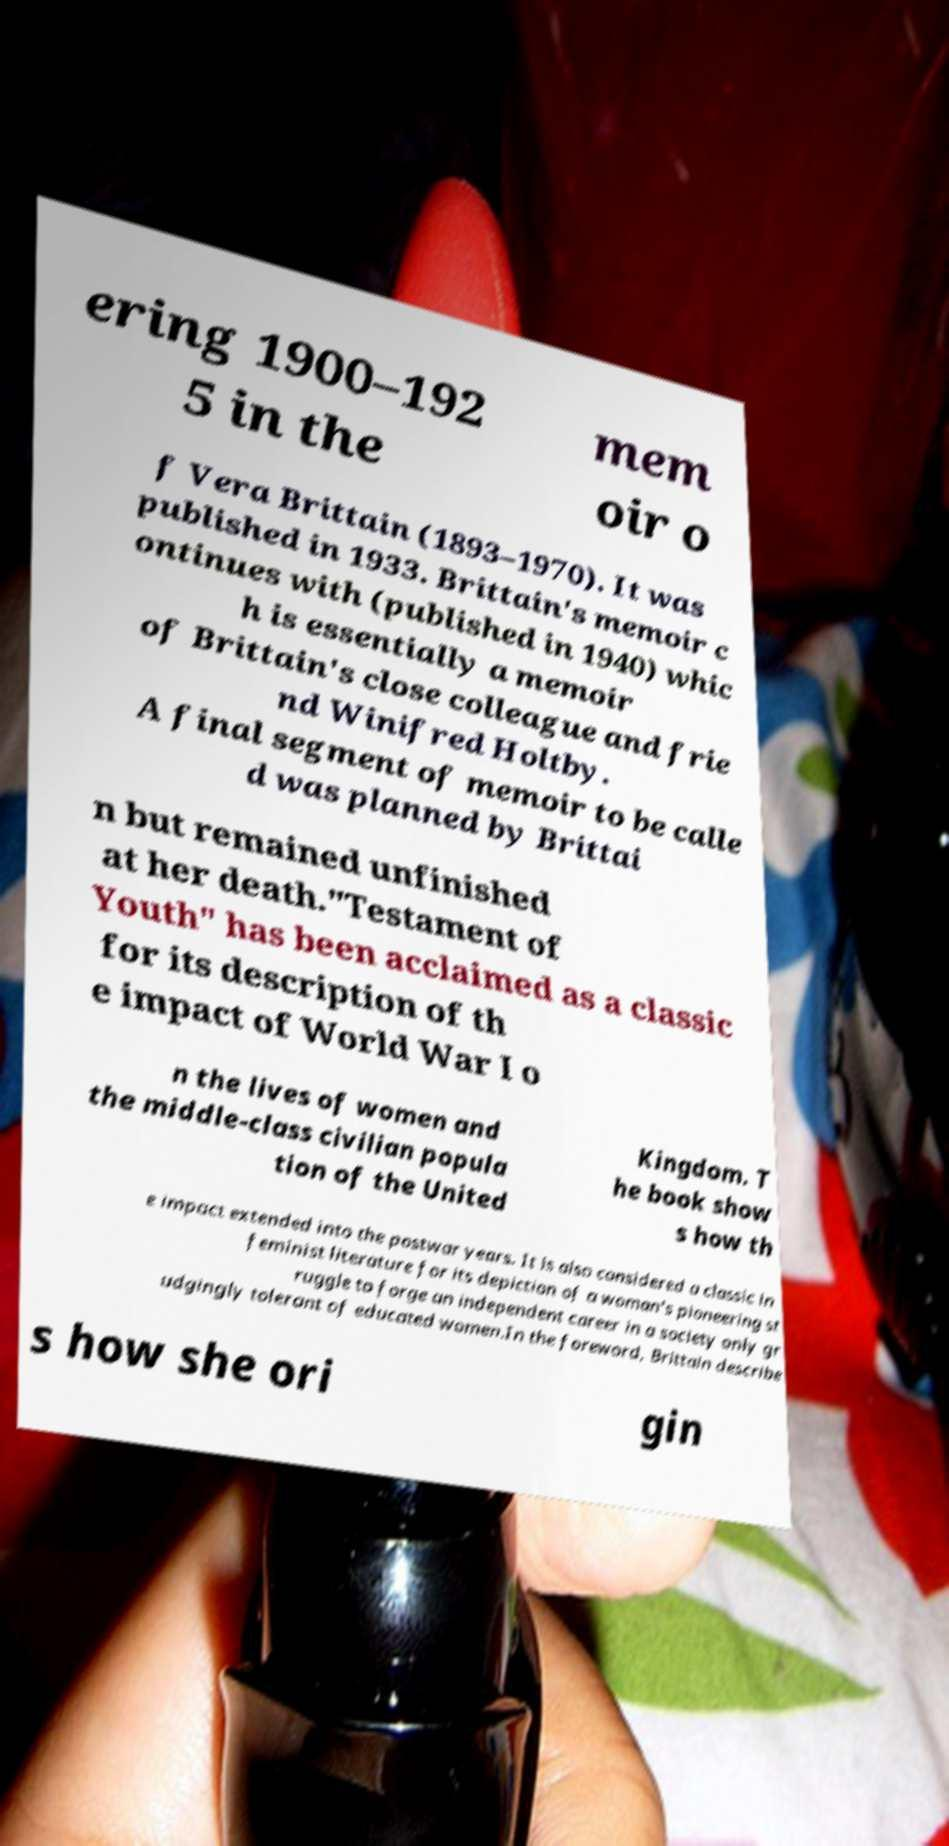What messages or text are displayed in this image? I need them in a readable, typed format. ering 1900–192 5 in the mem oir o f Vera Brittain (1893–1970). It was published in 1933. Brittain's memoir c ontinues with (published in 1940) whic h is essentially a memoir of Brittain's close colleague and frie nd Winifred Holtby. A final segment of memoir to be calle d was planned by Brittai n but remained unfinished at her death."Testament of Youth" has been acclaimed as a classic for its description of th e impact of World War I o n the lives of women and the middle-class civilian popula tion of the United Kingdom. T he book show s how th e impact extended into the postwar years. It is also considered a classic in feminist literature for its depiction of a woman's pioneering st ruggle to forge an independent career in a society only gr udgingly tolerant of educated women.In the foreword, Brittain describe s how she ori gin 